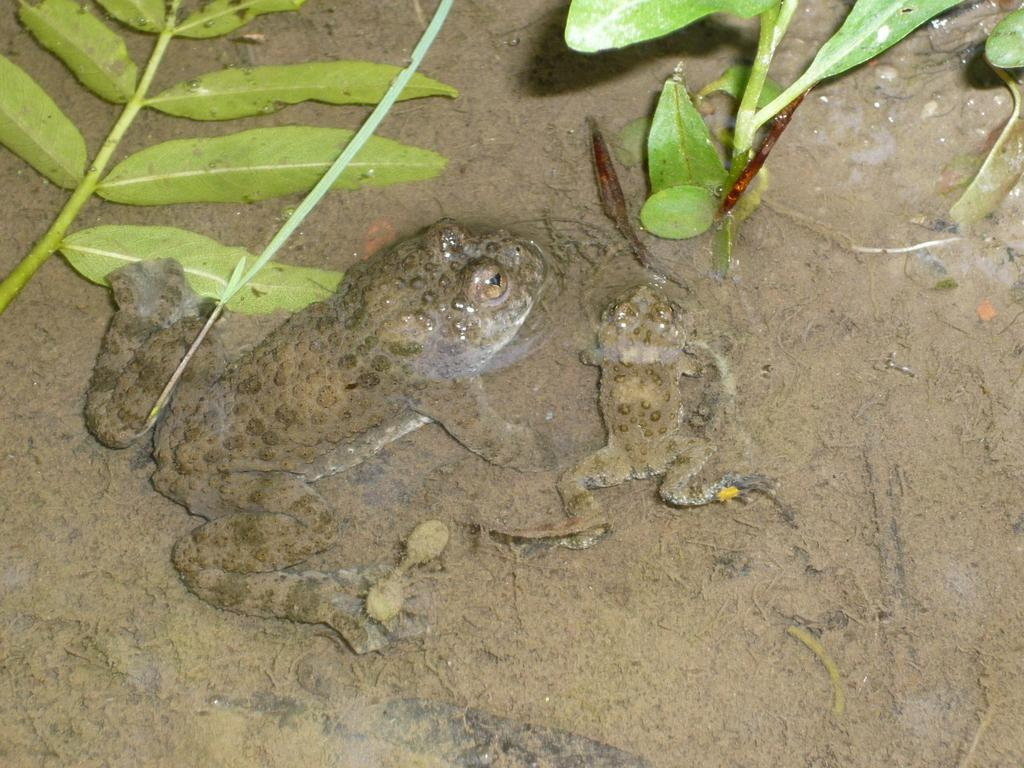What animals are present in the sand in the image? There are two frogs in the sand. What type of vegetation is visible at the top of the image? There are green leaves and small plants at the top of the image. Can you see an umbrella in the image? No, there is no umbrella present in the image. What type of ball is being played with by the frogs in the image? There are no frogs playing with a ball in the image; the frogs are simply in the sand. 